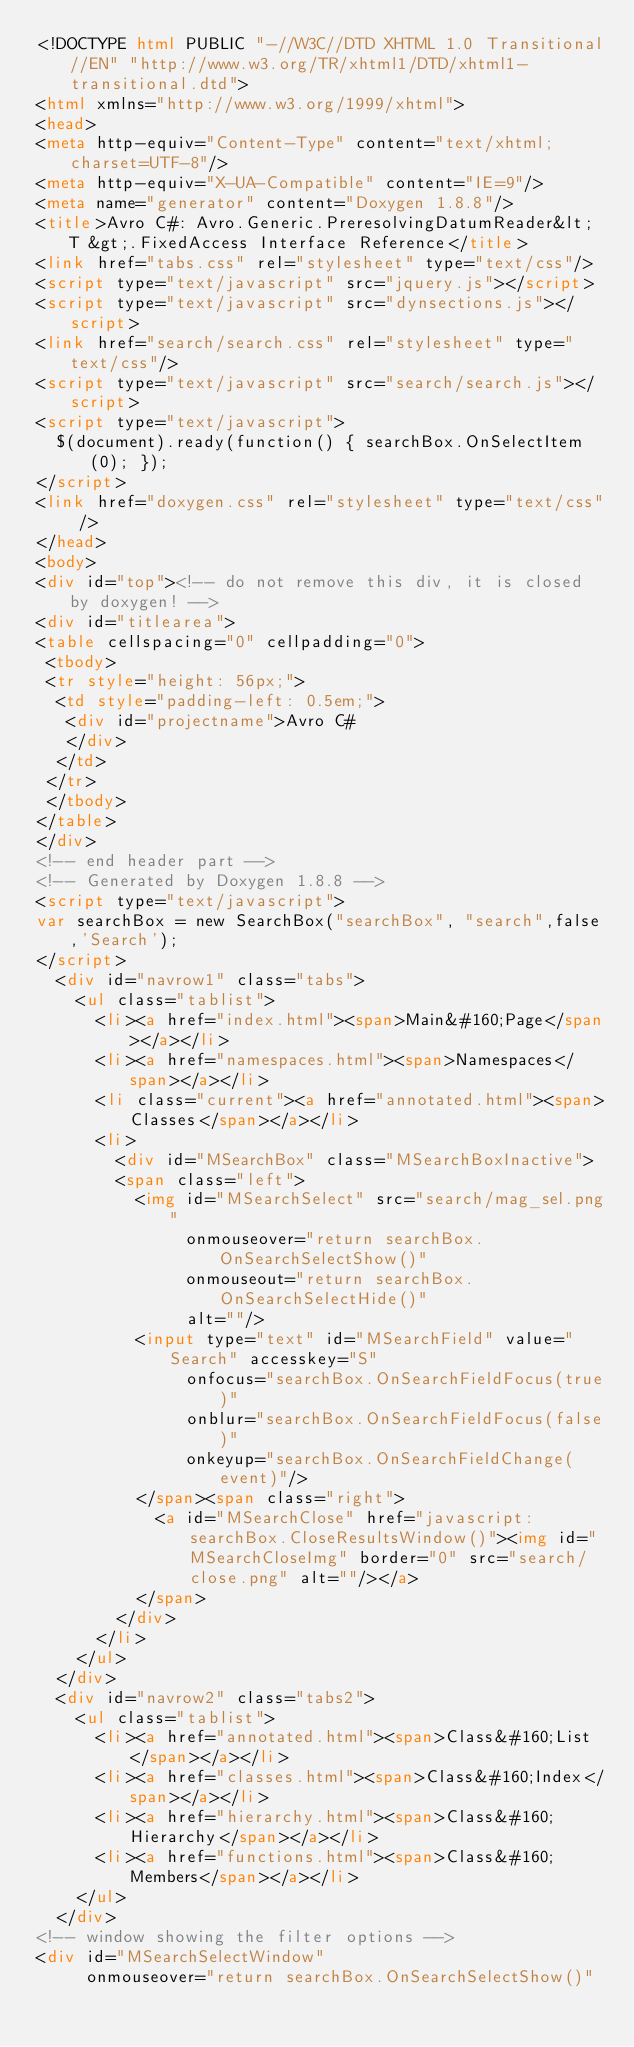<code> <loc_0><loc_0><loc_500><loc_500><_HTML_><!DOCTYPE html PUBLIC "-//W3C//DTD XHTML 1.0 Transitional//EN" "http://www.w3.org/TR/xhtml1/DTD/xhtml1-transitional.dtd">
<html xmlns="http://www.w3.org/1999/xhtml">
<head>
<meta http-equiv="Content-Type" content="text/xhtml;charset=UTF-8"/>
<meta http-equiv="X-UA-Compatible" content="IE=9"/>
<meta name="generator" content="Doxygen 1.8.8"/>
<title>Avro C#: Avro.Generic.PreresolvingDatumReader&lt; T &gt;.FixedAccess Interface Reference</title>
<link href="tabs.css" rel="stylesheet" type="text/css"/>
<script type="text/javascript" src="jquery.js"></script>
<script type="text/javascript" src="dynsections.js"></script>
<link href="search/search.css" rel="stylesheet" type="text/css"/>
<script type="text/javascript" src="search/search.js"></script>
<script type="text/javascript">
  $(document).ready(function() { searchBox.OnSelectItem(0); });
</script>
<link href="doxygen.css" rel="stylesheet" type="text/css" />
</head>
<body>
<div id="top"><!-- do not remove this div, it is closed by doxygen! -->
<div id="titlearea">
<table cellspacing="0" cellpadding="0">
 <tbody>
 <tr style="height: 56px;">
  <td style="padding-left: 0.5em;">
   <div id="projectname">Avro C#
   </div>
  </td>
 </tr>
 </tbody>
</table>
</div>
<!-- end header part -->
<!-- Generated by Doxygen 1.8.8 -->
<script type="text/javascript">
var searchBox = new SearchBox("searchBox", "search",false,'Search');
</script>
  <div id="navrow1" class="tabs">
    <ul class="tablist">
      <li><a href="index.html"><span>Main&#160;Page</span></a></li>
      <li><a href="namespaces.html"><span>Namespaces</span></a></li>
      <li class="current"><a href="annotated.html"><span>Classes</span></a></li>
      <li>
        <div id="MSearchBox" class="MSearchBoxInactive">
        <span class="left">
          <img id="MSearchSelect" src="search/mag_sel.png"
               onmouseover="return searchBox.OnSearchSelectShow()"
               onmouseout="return searchBox.OnSearchSelectHide()"
               alt=""/>
          <input type="text" id="MSearchField" value="Search" accesskey="S"
               onfocus="searchBox.OnSearchFieldFocus(true)" 
               onblur="searchBox.OnSearchFieldFocus(false)" 
               onkeyup="searchBox.OnSearchFieldChange(event)"/>
          </span><span class="right">
            <a id="MSearchClose" href="javascript:searchBox.CloseResultsWindow()"><img id="MSearchCloseImg" border="0" src="search/close.png" alt=""/></a>
          </span>
        </div>
      </li>
    </ul>
  </div>
  <div id="navrow2" class="tabs2">
    <ul class="tablist">
      <li><a href="annotated.html"><span>Class&#160;List</span></a></li>
      <li><a href="classes.html"><span>Class&#160;Index</span></a></li>
      <li><a href="hierarchy.html"><span>Class&#160;Hierarchy</span></a></li>
      <li><a href="functions.html"><span>Class&#160;Members</span></a></li>
    </ul>
  </div>
<!-- window showing the filter options -->
<div id="MSearchSelectWindow"
     onmouseover="return searchBox.OnSearchSelectShow()"</code> 